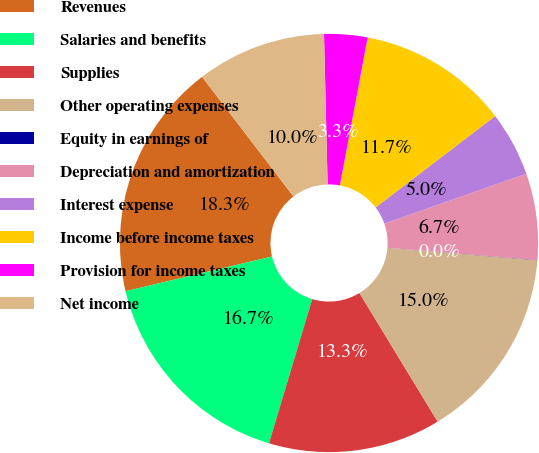<chart> <loc_0><loc_0><loc_500><loc_500><pie_chart><fcel>Revenues<fcel>Salaries and benefits<fcel>Supplies<fcel>Other operating expenses<fcel>Equity in earnings of<fcel>Depreciation and amortization<fcel>Interest expense<fcel>Income before income taxes<fcel>Provision for income taxes<fcel>Net income<nl><fcel>18.32%<fcel>16.66%<fcel>13.33%<fcel>14.99%<fcel>0.02%<fcel>6.67%<fcel>5.01%<fcel>11.66%<fcel>3.34%<fcel>10.0%<nl></chart> 